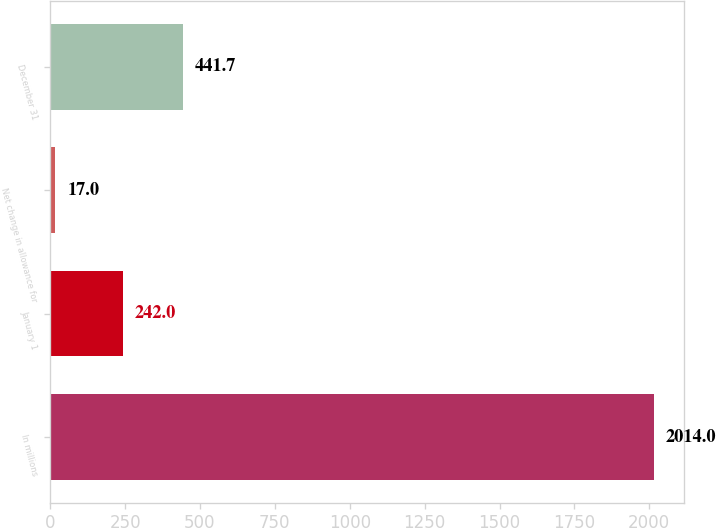Convert chart to OTSL. <chart><loc_0><loc_0><loc_500><loc_500><bar_chart><fcel>In millions<fcel>January 1<fcel>Net change in allowance for<fcel>December 31<nl><fcel>2014<fcel>242<fcel>17<fcel>441.7<nl></chart> 